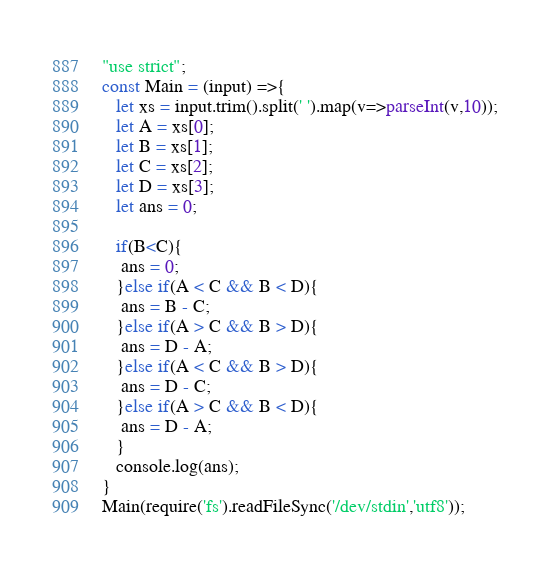Convert code to text. <code><loc_0><loc_0><loc_500><loc_500><_JavaScript_>"use strict";
const Main = (input) =>{
   let xs = input.trim().split(' ').map(v=>parseInt(v,10));
   let A = xs[0];
   let B = xs[1];
   let C = xs[2];
   let D = xs[3];
   let ans = 0;
   
   if(B<C){
    ans = 0;
   }else if(A < C && B < D){
    ans = B - C;
   }else if(A > C && B > D){
    ans = D - A;
   }else if(A < C && B > D){
    ans = D - C;
   }else if(A > C && B < D){
    ans = D - A;
   }
   console.log(ans);
}
Main(require('fs').readFileSync('/dev/stdin','utf8'));


</code> 